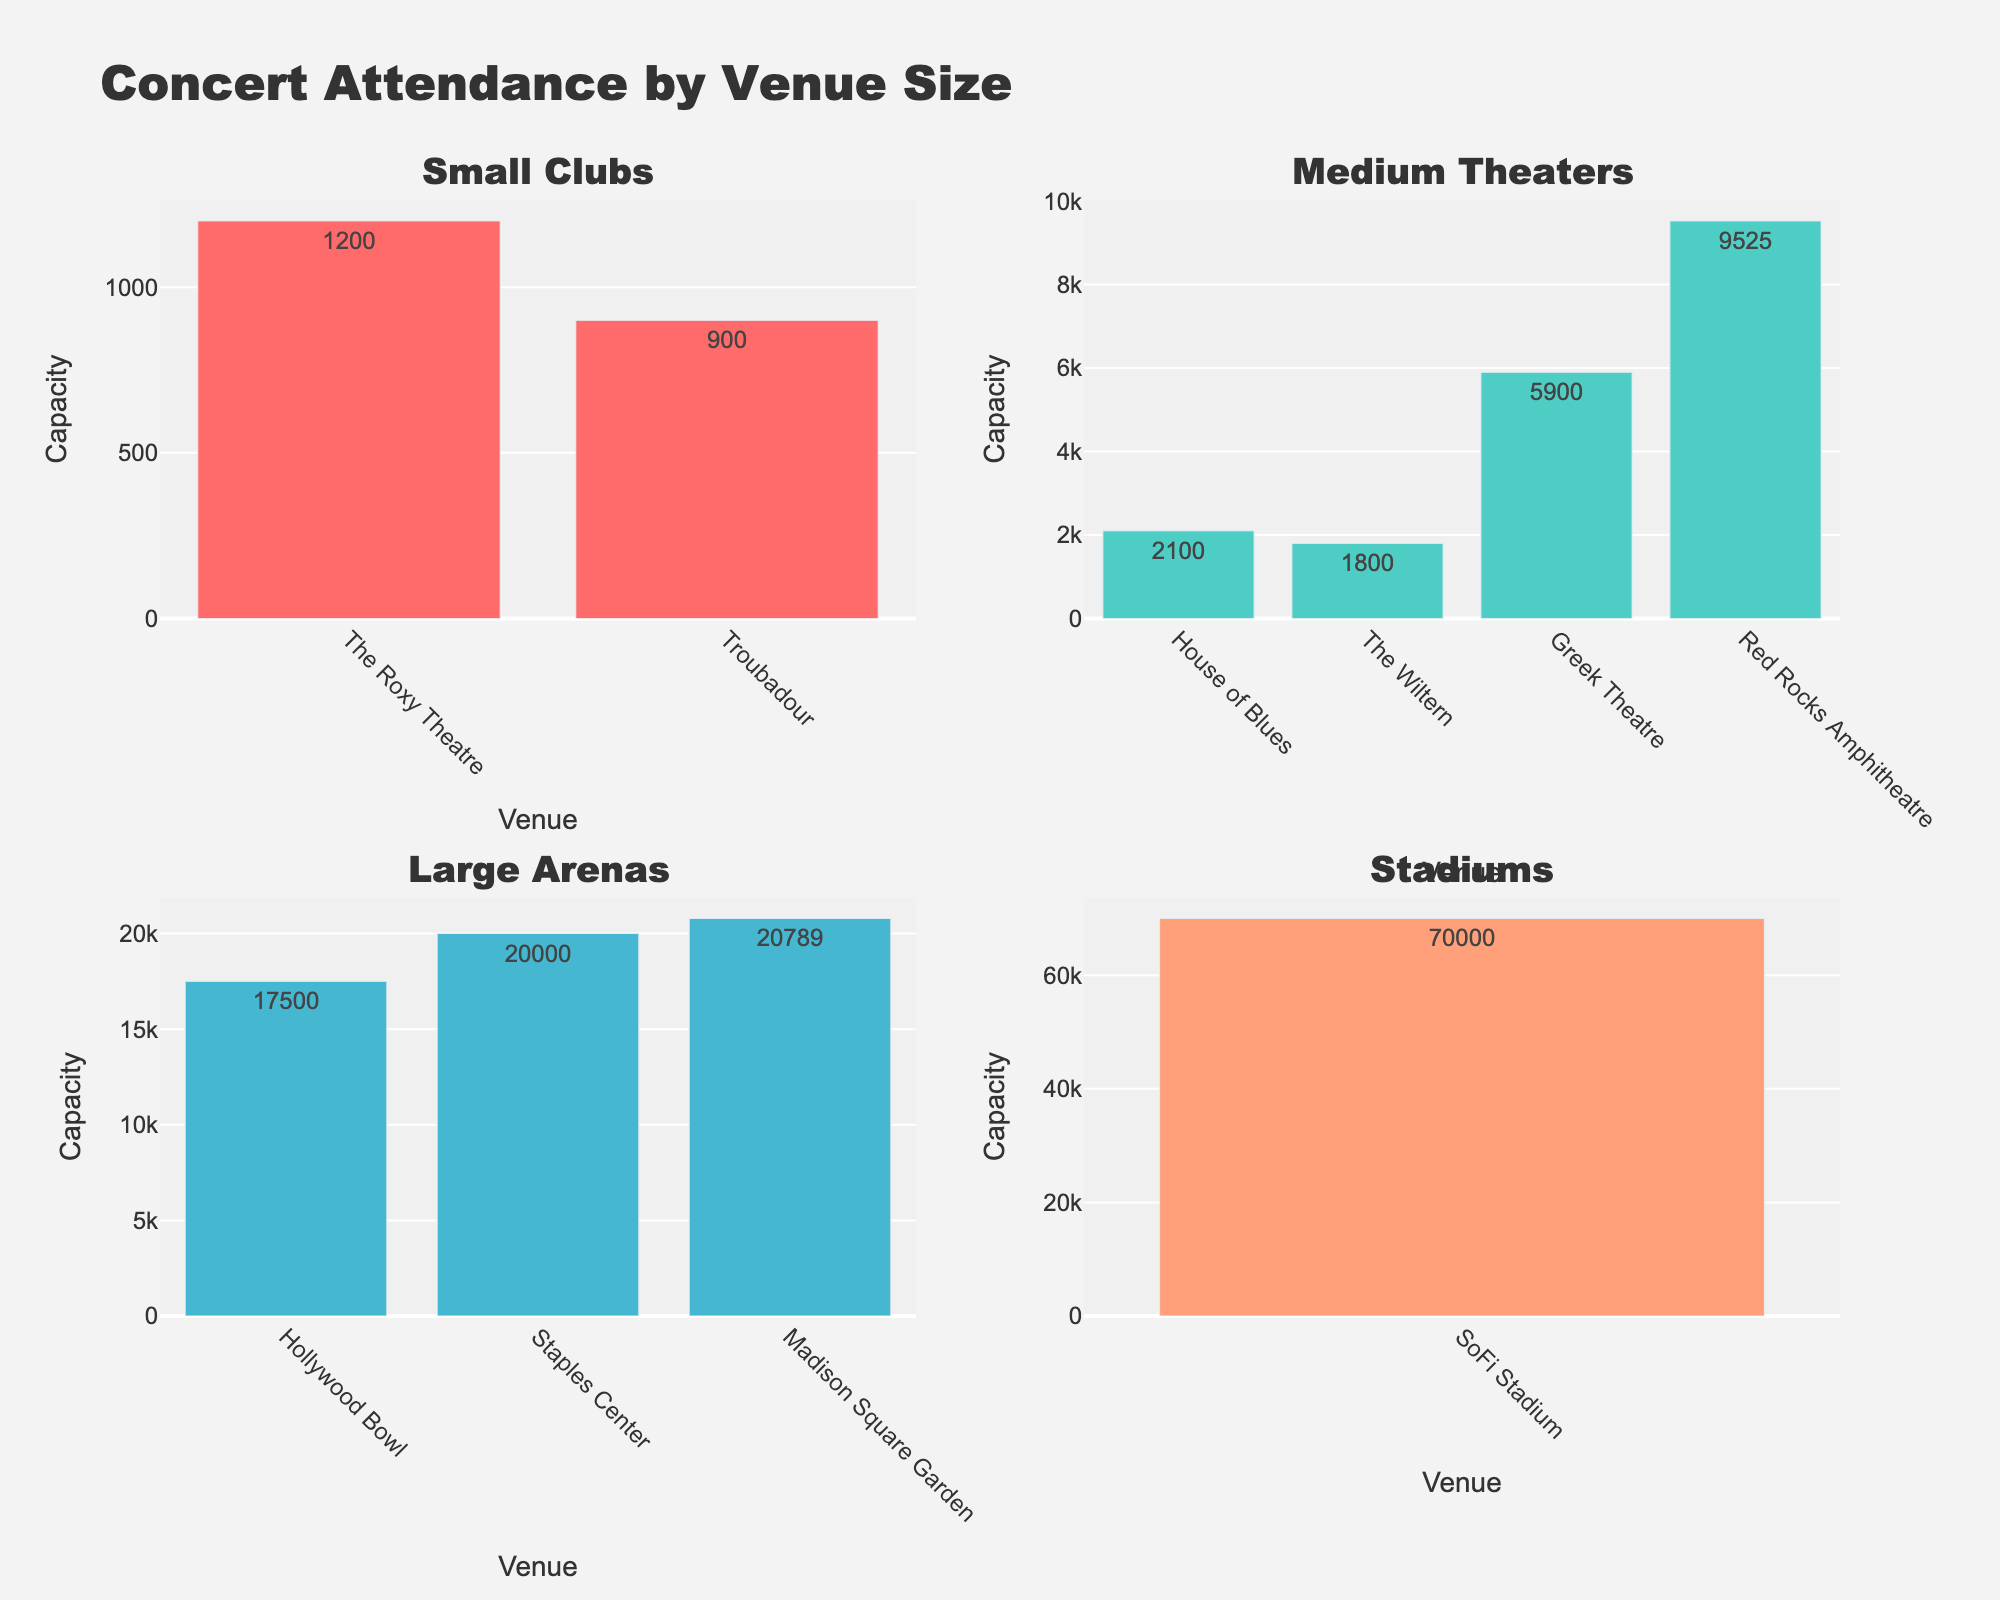How many subplots are in the figure? The figure consists of 4 subplots corresponding to the 4 venue types, arranged in a 2x2 grid as seen by the individual sections labeled for each venue type.
Answer: 4 What is the title of the figure? The title of the figure can be found at the very top, it reads "Concert Attendance by Venue Size".
Answer: Concert Attendance by Venue Size Which venue type has the largest number of attendees? By looking at the subplots, we can see the bar heights across each venue type. The Stadiums subplot has the highest values with SoFi Stadium holding 70,000 attendees.
Answer: Stadiums How many venues are classified under 'Medium Theaters'? In the subplot titled 'Medium Theaters', there are four bars, each representing a different venue.
Answer: 4 What's the total attendance for Small Clubs venues? Sum the values shown on the bars for 'Small Clubs': The Roxy Theatre (1200) + Troubadour (900). Thus, total attendance = 1200 + 900.
Answer: 2100 What's the average capacity for Medium Theatres venues? Sum the capacities of Medium Theaters venues and divide by the count. (2100 for House of Blues + 1800 for The Wiltern + 5900 for Greek Theatre + 9525 for Red Rocks Amphitheatre) = 19325, and there are 4 venues. So, 19325 ÷ 4.
Answer: 4831.25 Which venue in the Large Arenas category has the highest capacity? Looking at the 'Large Arenas' subplot, the highest bar is for Madison Square Garden with a capacity of 20,789.
Answer: Madison Square Garden How many venues have capacities higher than 10,000? Checking all subplots, the venues with capacities over 10,000 are Greek Theatre (5900 is not over 10K), Hollywood Bowl (17500), Madison Square Garden (20789), Staples Center (20000), and SoFi Stadium (70000). So, there are 4 venues.
Answer: 4 Compare the highest attendance from Small Clubs and Medium Theaters. By observing the highest bar in the 'Small Clubs' subplot (The Roxy Theatre: 1200) and the highest bar in the 'Medium Theaters' subplot (Red Rocks Amphitheatre: 9525), Red Rocks Amphitheatre in 'Medium Theaters' is significantly higher.
Answer: Medium Theaters Which venue under 'Large Arenas' has the smallest attendance? In the 'Large Arenas' subplot, the 'Hollywood Bowl' has the smallest attendance with 17,500.
Answer: Hollywood Bowl 